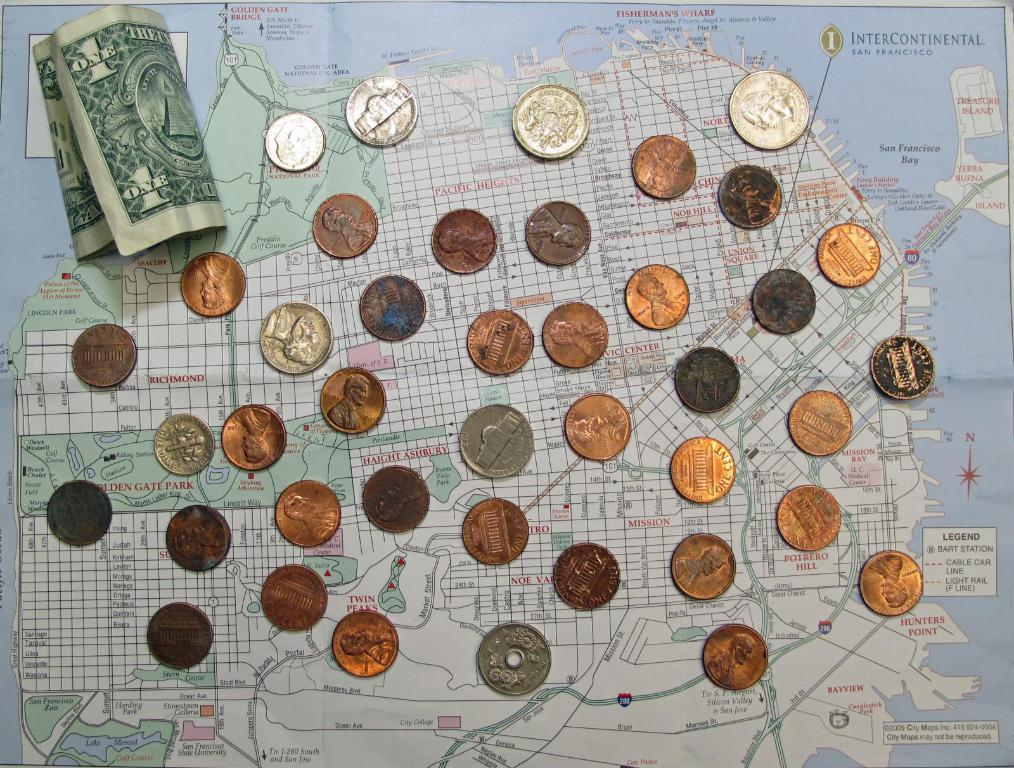<image>
Create a compact narrative representing the image presented. A one dollar bill is rolled up next to a bunch of coins. 